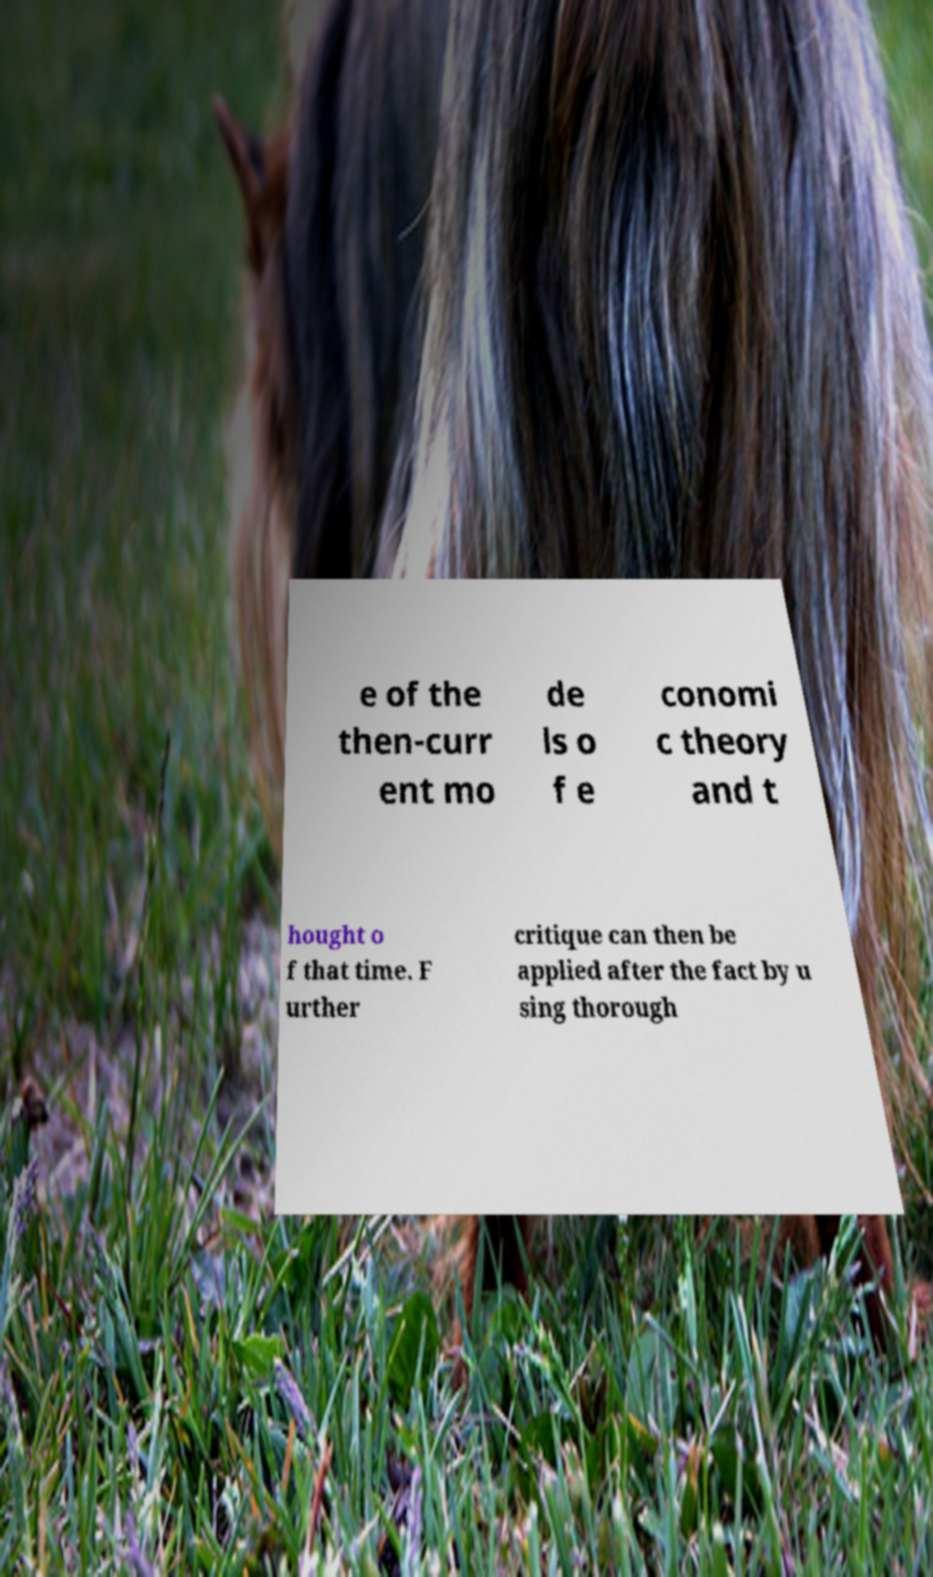Could you extract and type out the text from this image? e of the then-curr ent mo de ls o f e conomi c theory and t hought o f that time. F urther critique can then be applied after the fact by u sing thorough 